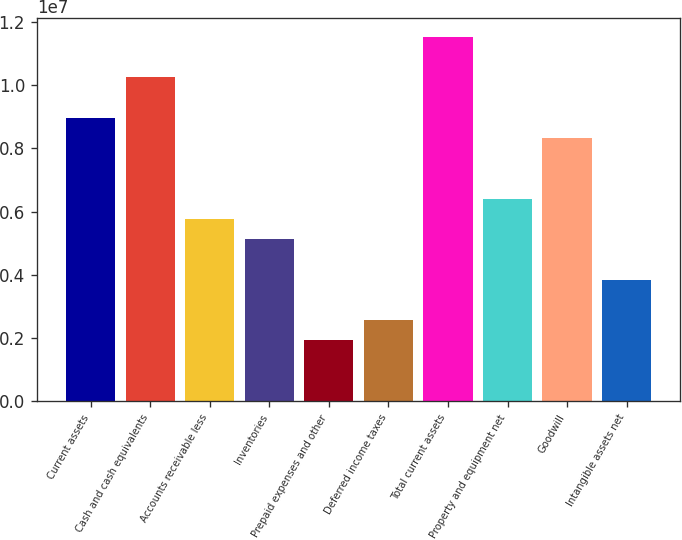<chart> <loc_0><loc_0><loc_500><loc_500><bar_chart><fcel>Current assets<fcel>Cash and cash equivalents<fcel>Accounts receivable less<fcel>Inventories<fcel>Prepaid expenses and other<fcel>Deferred income taxes<fcel>Total current assets<fcel>Property and equipment net<fcel>Goodwill<fcel>Intangible assets net<nl><fcel>8.97686e+06<fcel>1.02592e+07<fcel>5.77109e+06<fcel>5.12994e+06<fcel>1.92418e+06<fcel>2.56533e+06<fcel>1.15415e+07<fcel>6.41224e+06<fcel>8.3357e+06<fcel>3.84764e+06<nl></chart> 